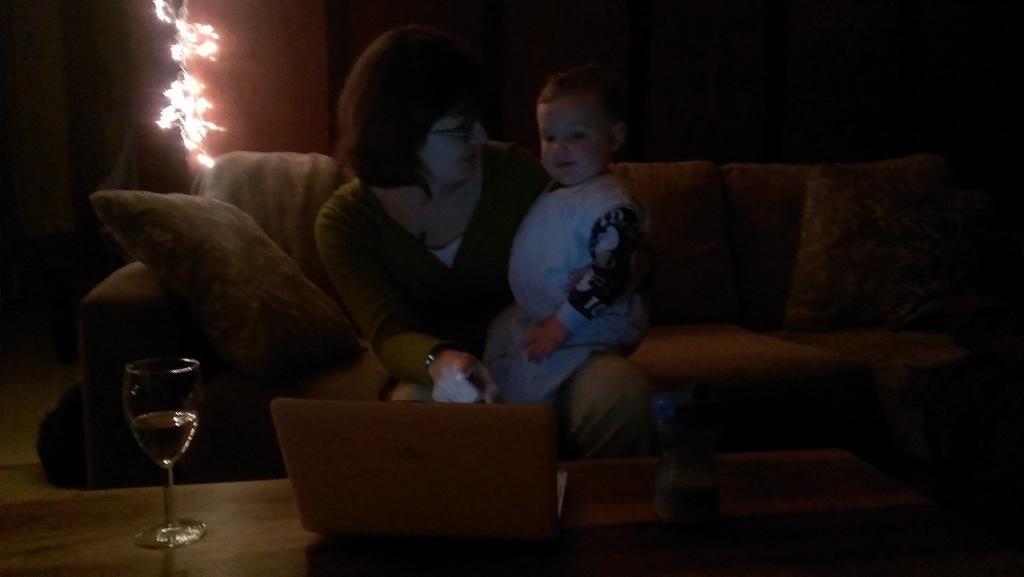Could you give a brief overview of what you see in this image? There is a women sitting on the couch and a small boy sitting on woman's lap. This is a couch and a cushion placed on it. This is a table where a laptop and a wine glass are placed. At background I can see lights. 